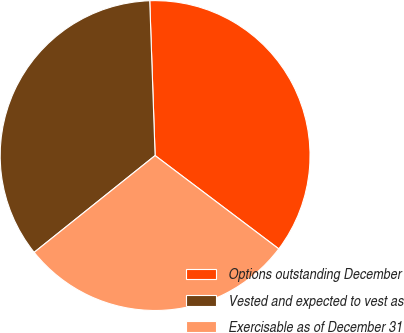Convert chart to OTSL. <chart><loc_0><loc_0><loc_500><loc_500><pie_chart><fcel>Options outstanding December<fcel>Vested and expected to vest as<fcel>Exercisable as of December 31<nl><fcel>35.84%<fcel>35.19%<fcel>28.97%<nl></chart> 